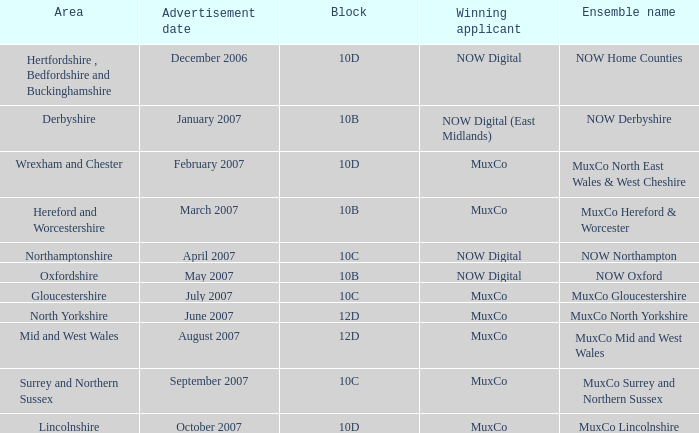Who has been awarded the ensemble name muxco lincolnshire in block 10d? MuxCo. 